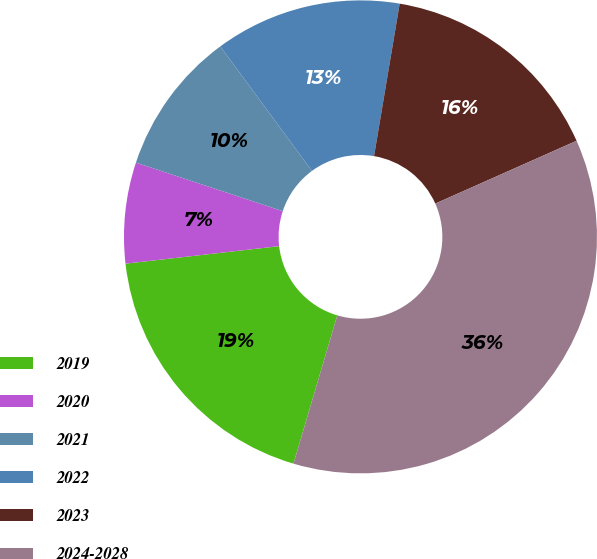Convert chart. <chart><loc_0><loc_0><loc_500><loc_500><pie_chart><fcel>2019<fcel>2020<fcel>2021<fcel>2022<fcel>2023<fcel>2024-2028<nl><fcel>18.62%<fcel>6.89%<fcel>9.82%<fcel>12.75%<fcel>15.69%<fcel>36.23%<nl></chart> 